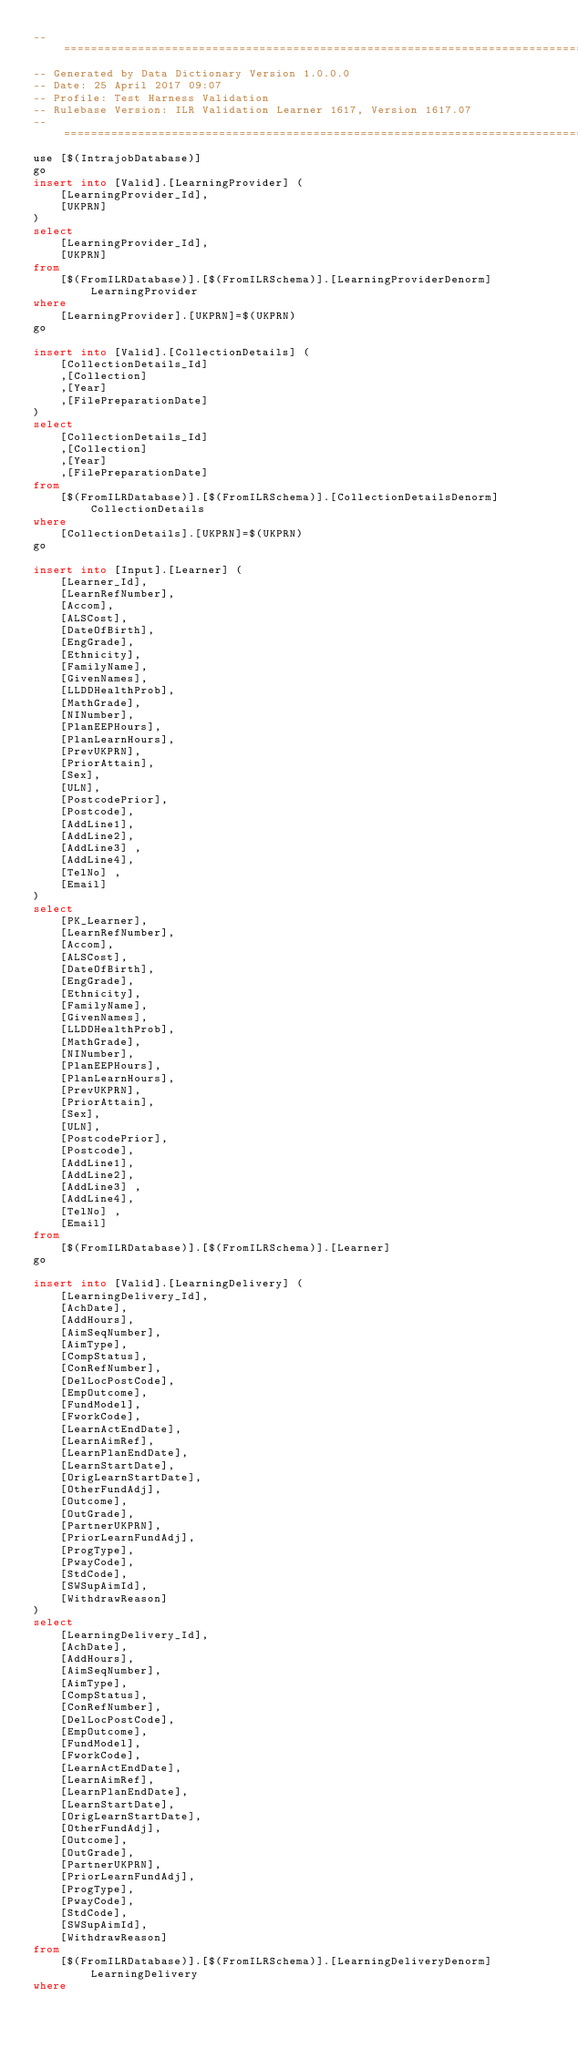Convert code to text. <code><loc_0><loc_0><loc_500><loc_500><_SQL_>-- =====================================================================================================
-- Generated by Data Dictionary Version 1.0.0.0
-- Date: 25 April 2017 09:07
-- Profile: Test Harness Validation
-- Rulebase Version: ILR Validation Learner 1617, Version 1617.07
-- =====================================================================================================
use [$(IntrajobDatabase)]
go
insert into [Valid].[LearningProvider] (
	[LearningProvider_Id],
	[UKPRN]
)
select
	[LearningProvider_Id],
	[UKPRN]
from
	[$(FromILRDatabase)].[$(FromILRSchema)].[LearningProviderDenorm] LearningProvider
where
	[LearningProvider].[UKPRN]=$(UKPRN)
go

insert into [Valid].[CollectionDetails] (
	[CollectionDetails_Id]
	,[Collection] 
	,[Year]
	,[FilePreparationDate]
)
select
	[CollectionDetails_Id]
	,[Collection] 
	,[Year]
	,[FilePreparationDate]
from
	[$(FromILRDatabase)].[$(FromILRSchema)].[CollectionDetailsDenorm] CollectionDetails
where
	[CollectionDetails].[UKPRN]=$(UKPRN)
go

insert into [Input].[Learner] (
	[Learner_Id],
	[LearnRefNumber],
	[Accom],
	[ALSCost],
	[DateOfBirth],
	[EngGrade],
	[Ethnicity],
	[FamilyName],
	[GivenNames],
	[LLDDHealthProb],
	[MathGrade],
	[NINumber],
	[PlanEEPHours],
	[PlanLearnHours],
	[PrevUKPRN],
	[PriorAttain],
	[Sex],
	[ULN],
	[PostcodePrior],
	[Postcode],
	[AddLine1],
	[AddLine2],
	[AddLine3] ,
	[AddLine4],
	[TelNo] ,
	[Email]
)
select
	[PK_Learner],
	[LearnRefNumber],
	[Accom],
	[ALSCost],
	[DateOfBirth],
	[EngGrade],
	[Ethnicity],
	[FamilyName],
	[GivenNames],
	[LLDDHealthProb],
	[MathGrade],
	[NINumber],
	[PlanEEPHours],
	[PlanLearnHours],
	[PrevUKPRN],
	[PriorAttain],
	[Sex],
	[ULN],
	[PostcodePrior],
	[Postcode],
	[AddLine1],
	[AddLine2],
	[AddLine3] ,
	[AddLine4],
	[TelNo] ,
	[Email]
from
	[$(FromILRDatabase)].[$(FromILRSchema)].[Learner]
go

insert into [Valid].[LearningDelivery] (
	[LearningDelivery_Id],
	[AchDate],
	[AddHours],
	[AimSeqNumber],
	[AimType],
	[CompStatus],
	[ConRefNumber],
	[DelLocPostCode],
	[EmpOutcome],
	[FundModel],
	[FworkCode],
	[LearnActEndDate],
	[LearnAimRef],
	[LearnPlanEndDate],
	[LearnStartDate],
	[OrigLearnStartDate],
	[OtherFundAdj],
	[Outcome],
	[OutGrade],
	[PartnerUKPRN],
	[PriorLearnFundAdj],
	[ProgType],
	[PwayCode],
	[StdCode],
	[SWSupAimId],
	[WithdrawReason]
)
select
	[LearningDelivery_Id],
	[AchDate],
	[AddHours],
	[AimSeqNumber],
	[AimType],
	[CompStatus],
	[ConRefNumber],
	[DelLocPostCode],
	[EmpOutcome],
	[FundModel],
	[FworkCode],
	[LearnActEndDate],
	[LearnAimRef],
	[LearnPlanEndDate],
	[LearnStartDate],
	[OrigLearnStartDate],
	[OtherFundAdj],
	[Outcome],
	[OutGrade],
	[PartnerUKPRN],
	[PriorLearnFundAdj],
	[ProgType],
	[PwayCode],
	[StdCode],
	[SWSupAimId],
	[WithdrawReason]
from
	[$(FromILRDatabase)].[$(FromILRSchema)].[LearningDeliveryDenorm] LearningDelivery
where</code> 